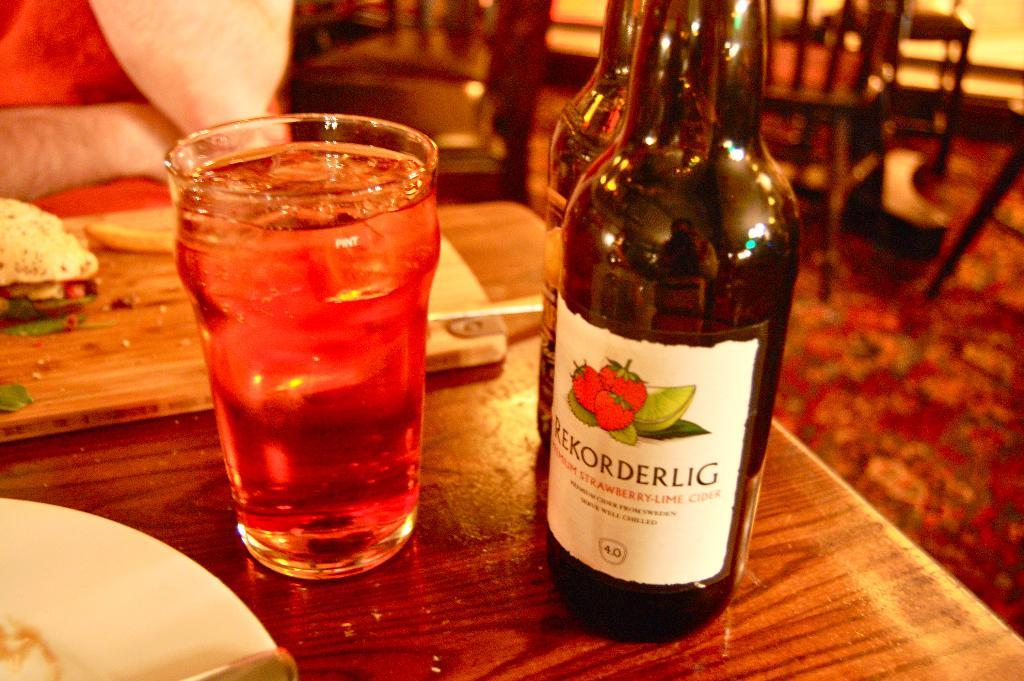<image>
Describe the image concisely. A bottle of Rekorderlig wine sits on a table in a restaurant. 